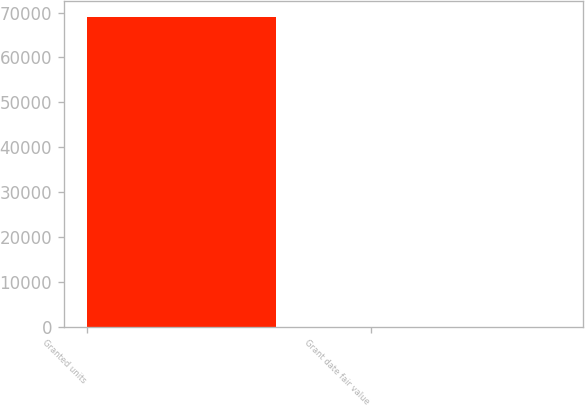Convert chart to OTSL. <chart><loc_0><loc_0><loc_500><loc_500><bar_chart><fcel>Granted units<fcel>Grant date fair value<nl><fcel>69044<fcel>22.6<nl></chart> 